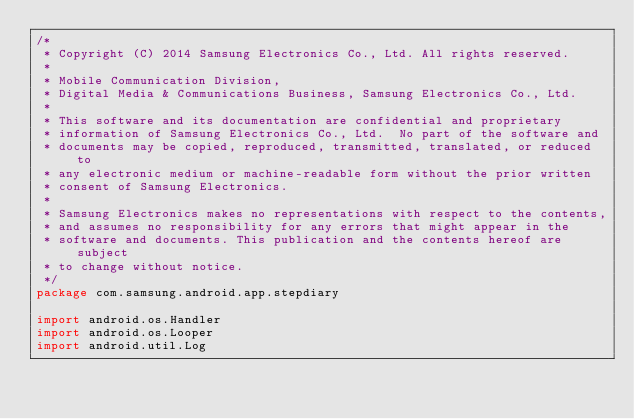<code> <loc_0><loc_0><loc_500><loc_500><_Kotlin_>/*
 * Copyright (C) 2014 Samsung Electronics Co., Ltd. All rights reserved.
 *
 * Mobile Communication Division,
 * Digital Media & Communications Business, Samsung Electronics Co., Ltd.
 *
 * This software and its documentation are confidential and proprietary
 * information of Samsung Electronics Co., Ltd.  No part of the software and
 * documents may be copied, reproduced, transmitted, translated, or reduced to
 * any electronic medium or machine-readable form without the prior written
 * consent of Samsung Electronics.
 *
 * Samsung Electronics makes no representations with respect to the contents,
 * and assumes no responsibility for any errors that might appear in the
 * software and documents. This publication and the contents hereof are subject
 * to change without notice.
 */
package com.samsung.android.app.stepdiary

import android.os.Handler
import android.os.Looper
import android.util.Log</code> 